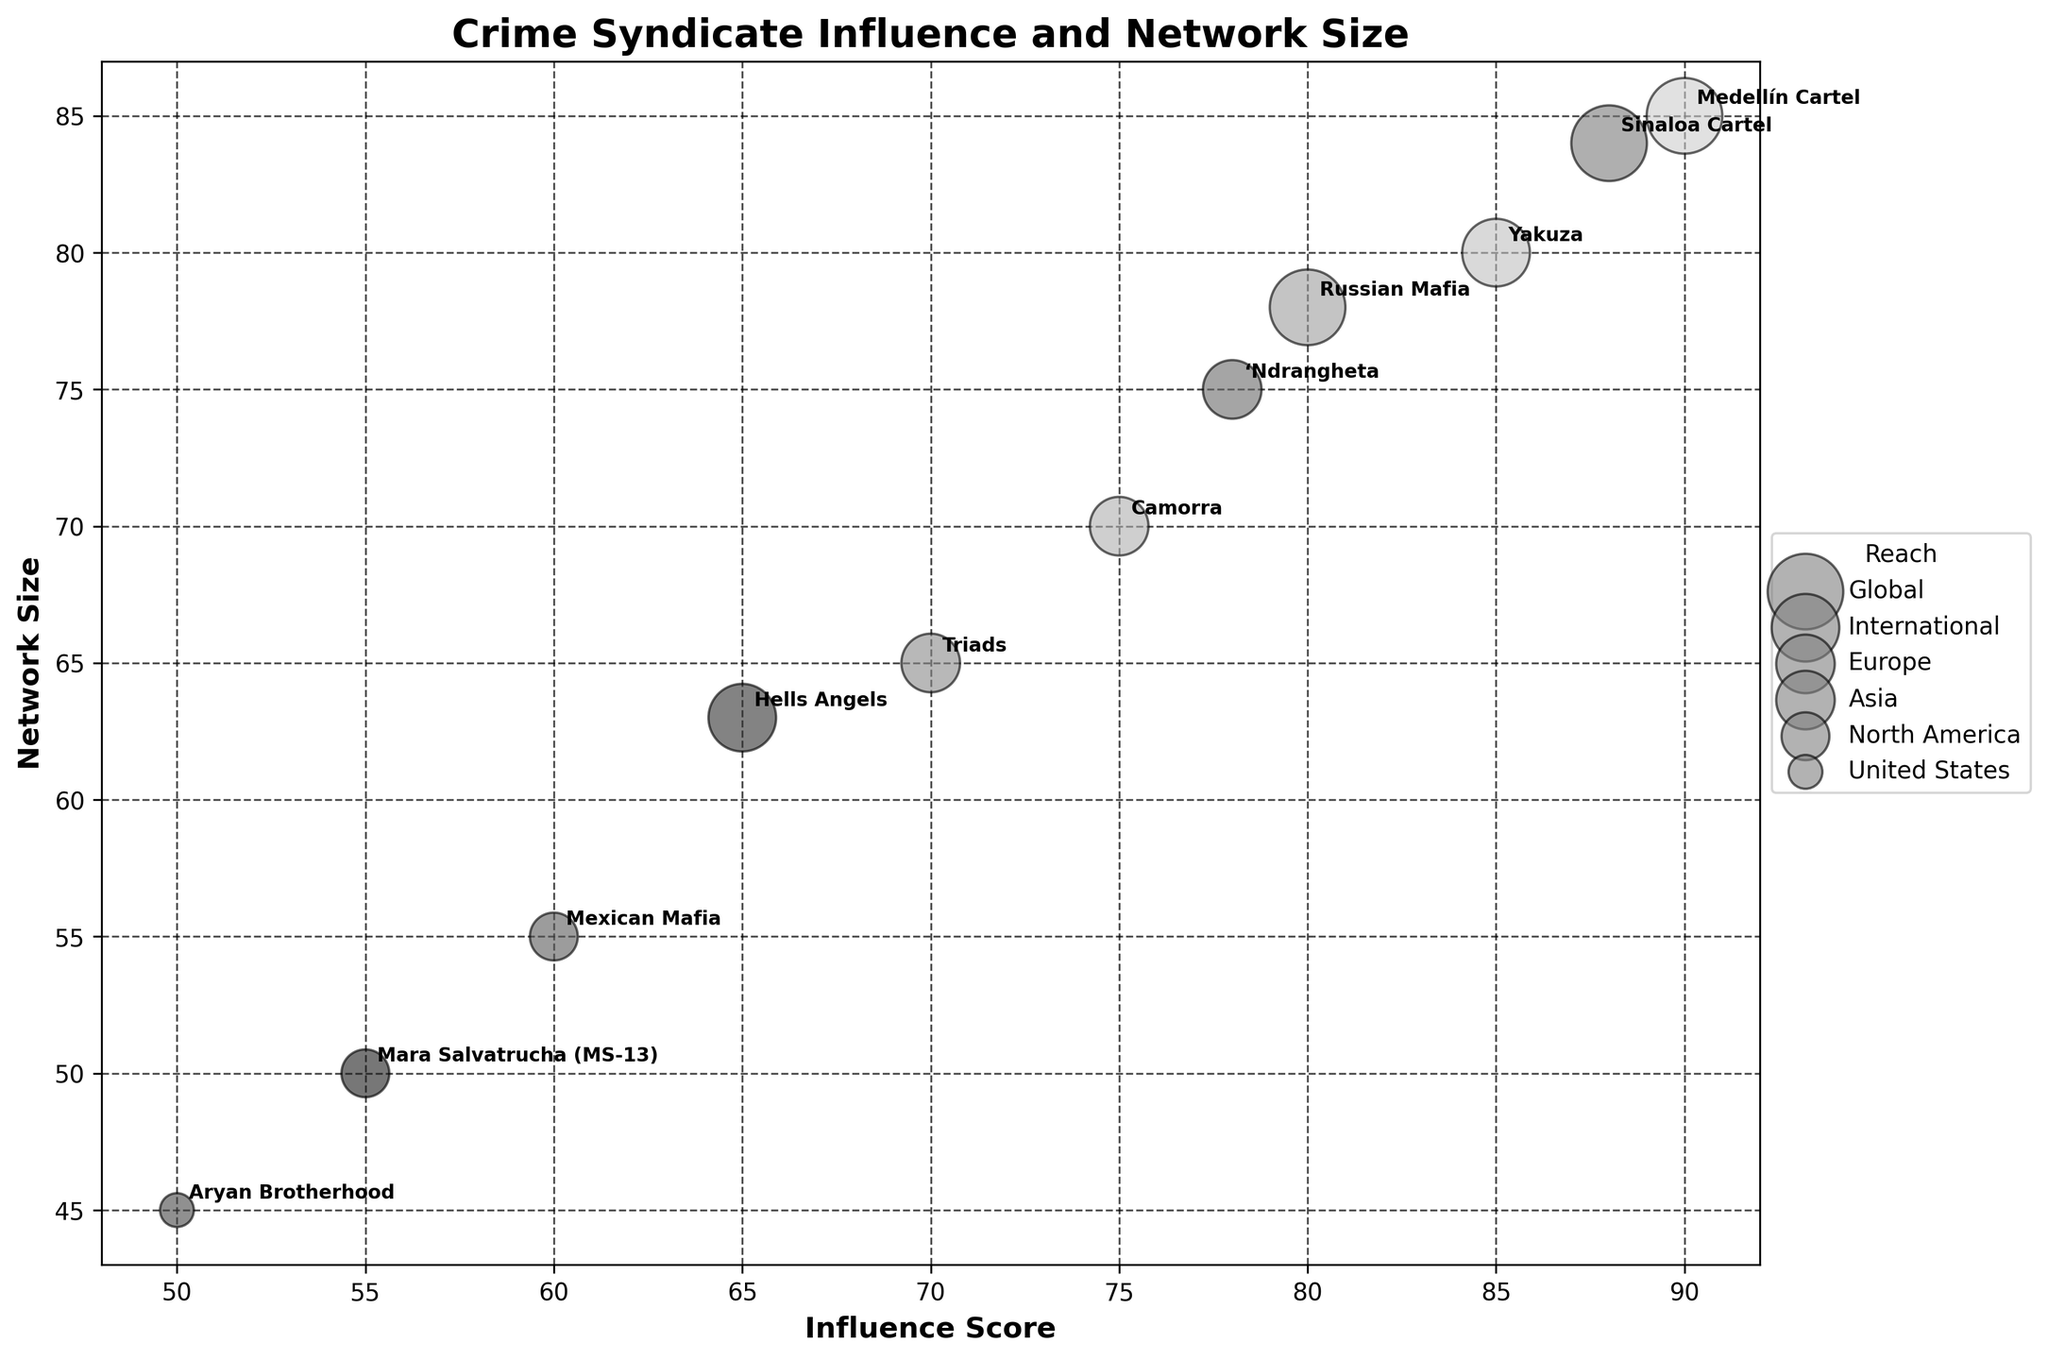Who has the highest Influence Score? The bubble with the highest Influence Score is located further to the right. By looking at the furthest right bubble, we can see that the Medellín Cartel has the highest Influence Score of 90.
Answer: Medellín Cartel Which crime syndicate has the smallest reach and what is its associated Network Size? The smallest reach corresponds to the smallest sized bubble, which is the United States. Looking at this bubble, the Aryan Brotherhood is the crime syndicate, and its Network Size is 45.
Answer: Aryan Brotherhood, 45 What is the range of the Network Sizes represented in the bubble chart? To determine the range, we identify the smallest and largest Network Size values. The Aryan Brotherhood has the smallest size of 45 and the Medellín Cartel has the largest size of 85. The range is calculated as 85 - 45.
Answer: 40 How many crime syndicates have a global reach? In the legend, the global reach is represented by the largest bubbles. By counting the number of these largest bubbles, we can see that there are three: Medellín Cartel, Russian Mafia, and Sinaloa Cartel.
Answer: Three Which crime syndicate has a larger Network Size: 'Ndrangheta or Triads? By comparing the positions of the 'Ndrangheta and Triads bubbles, we observe that the 'Ndrangheta (Network Size 75) is further right and higher than the Triads (Network Size 65).
Answer: 'Ndrangheta What is the average Network Size for crime syndicates with a European reach? By identifying and summing the Network Sizes of Camorra and ‘Ndrangheta, which have European reach (70 + 75), and then dividing by the number of syndicates (2), we get the average.
Answer: 72.5 For the crime syndicates with an international reach, compare the Influence Scores of Hells Angels and Yakuza. By locating the international reach bubbles for Hells Angels and Yakuza, we see their Influence Scores are 65 and 85 respectively. Yakuza has a higher Influence Score.
Answer: Yakuza Which crime syndicate's data point is closest to the center of the plot (average of X and Y axes)? The center can be approximated by averaging the range of both axes. By visually approximating the center point and comparing distances, the Russian Mafia’s bubble appears closest to the center.
Answer: Russian Mafia What is the influence score difference between the crime syndicate with the highest influence and the one with the lowest? The highest influence score is 90 (Medellín Cartel), and the lowest is 50 (Aryan Brotherhood), giving a difference of 90 - 50.
Answer: 40 